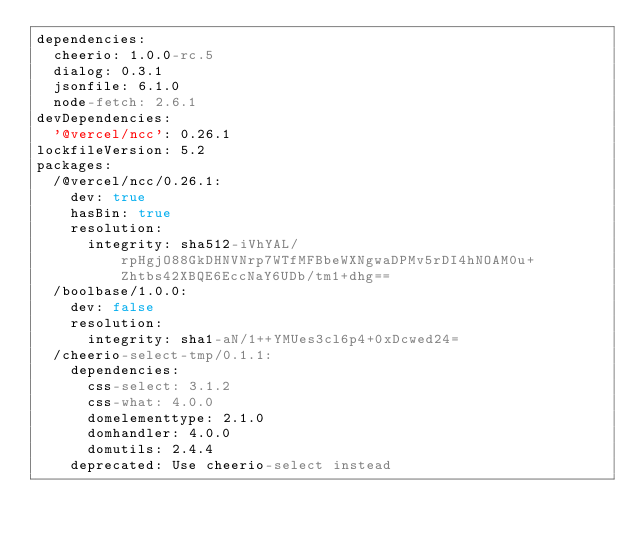<code> <loc_0><loc_0><loc_500><loc_500><_YAML_>dependencies:
  cheerio: 1.0.0-rc.5
  dialog: 0.3.1
  jsonfile: 6.1.0
  node-fetch: 2.6.1
devDependencies:
  '@vercel/ncc': 0.26.1
lockfileVersion: 5.2
packages:
  /@vercel/ncc/0.26.1:
    dev: true
    hasBin: true
    resolution:
      integrity: sha512-iVhYAL/rpHgjO88GkDHNVNrp7WTfMFBbeWXNgwaDPMv5rDI4hNOAM0u+Zhtbs42XBQE6EccNaY6UDb/tm1+dhg==
  /boolbase/1.0.0:
    dev: false
    resolution:
      integrity: sha1-aN/1++YMUes3cl6p4+0xDcwed24=
  /cheerio-select-tmp/0.1.1:
    dependencies:
      css-select: 3.1.2
      css-what: 4.0.0
      domelementtype: 2.1.0
      domhandler: 4.0.0
      domutils: 2.4.4
    deprecated: Use cheerio-select instead</code> 